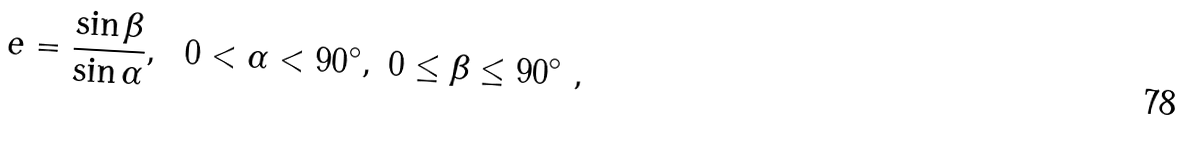Convert formula to latex. <formula><loc_0><loc_0><loc_500><loc_500>e = { \frac { \sin \beta } { \sin \alpha } } , \ \ 0 < \alpha < 9 0 ^ { \circ } , \ 0 \leq \beta \leq 9 0 ^ { \circ } \ ,</formula> 